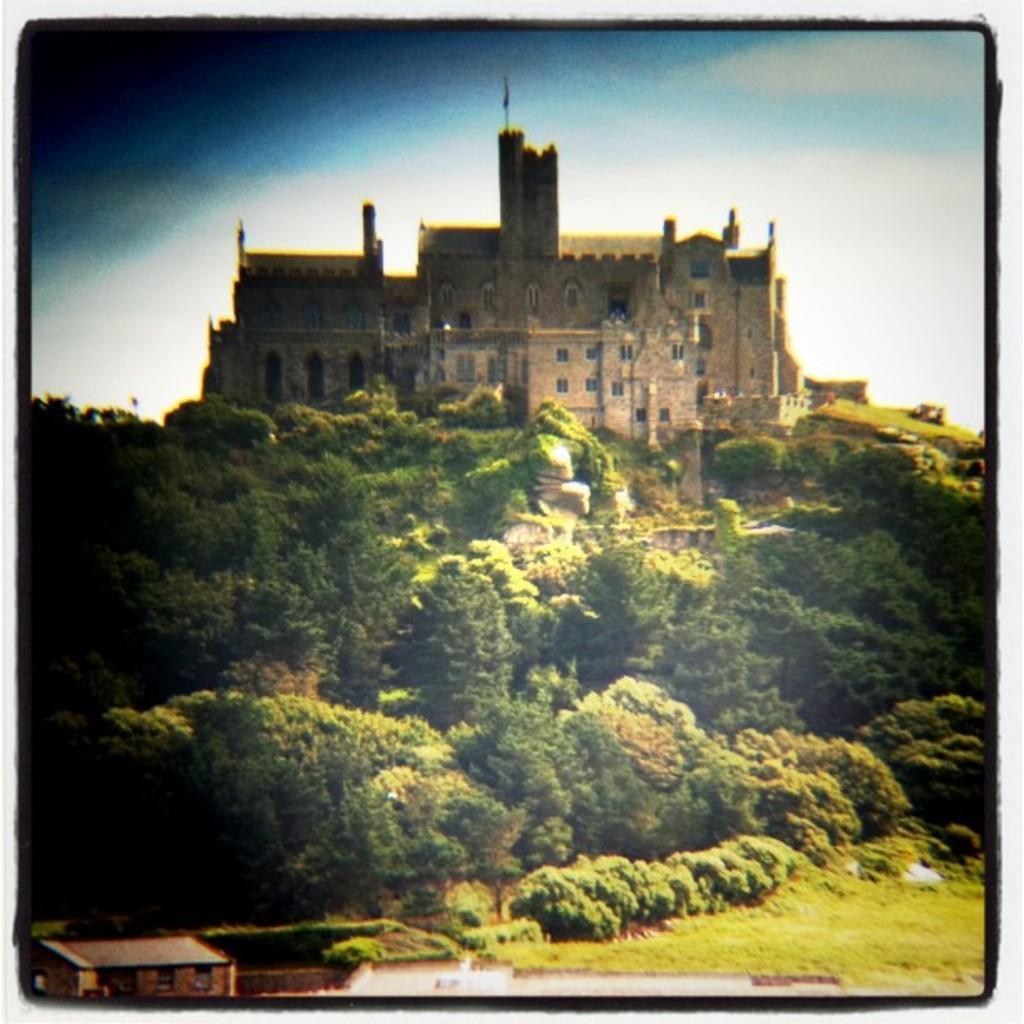Please provide a concise description of this image. In the image we can see some trees and grass and castle. Behind the castle there are some clouds and sky. In the bottom left corner of the image there is a building. 